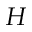<formula> <loc_0><loc_0><loc_500><loc_500>H</formula> 